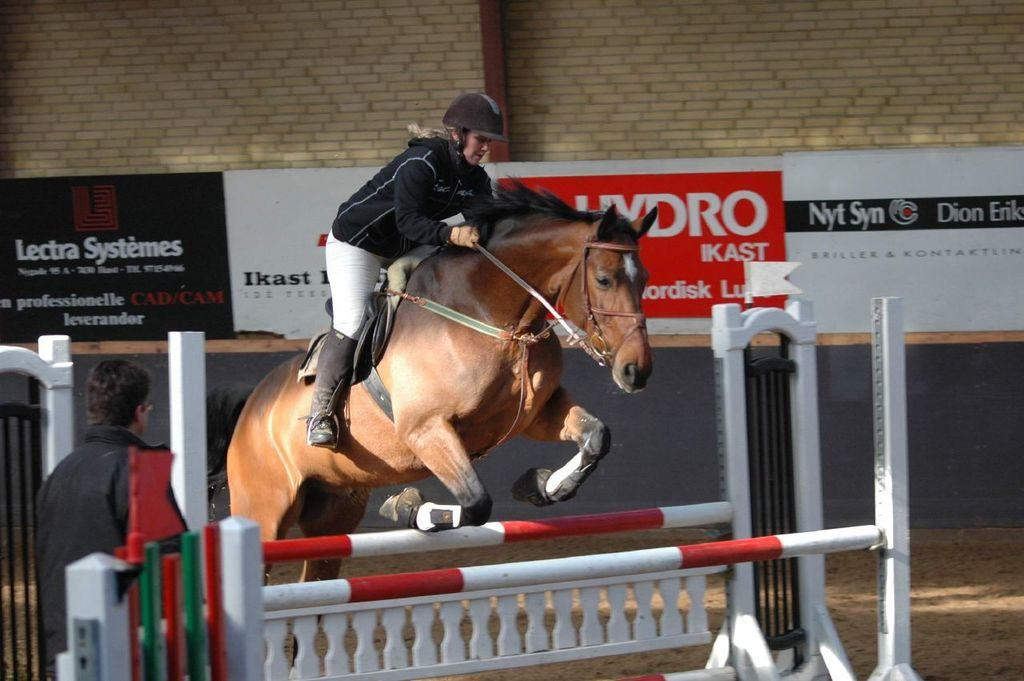What is the woman doing in the image? The woman is sitting on a horse and riding it. Who else is present in the image? There is another person standing nearby. What might be the purpose of the scene in the image? The scene appears to be a horse training session. What objects can be seen in the image? There are rods visible in the image. What can be seen in the background of the image? Banners are present in the background of the image. What type of vacation are the bears enjoying in the image? There are no bears present in the image, so it is not possible to answer that question. 